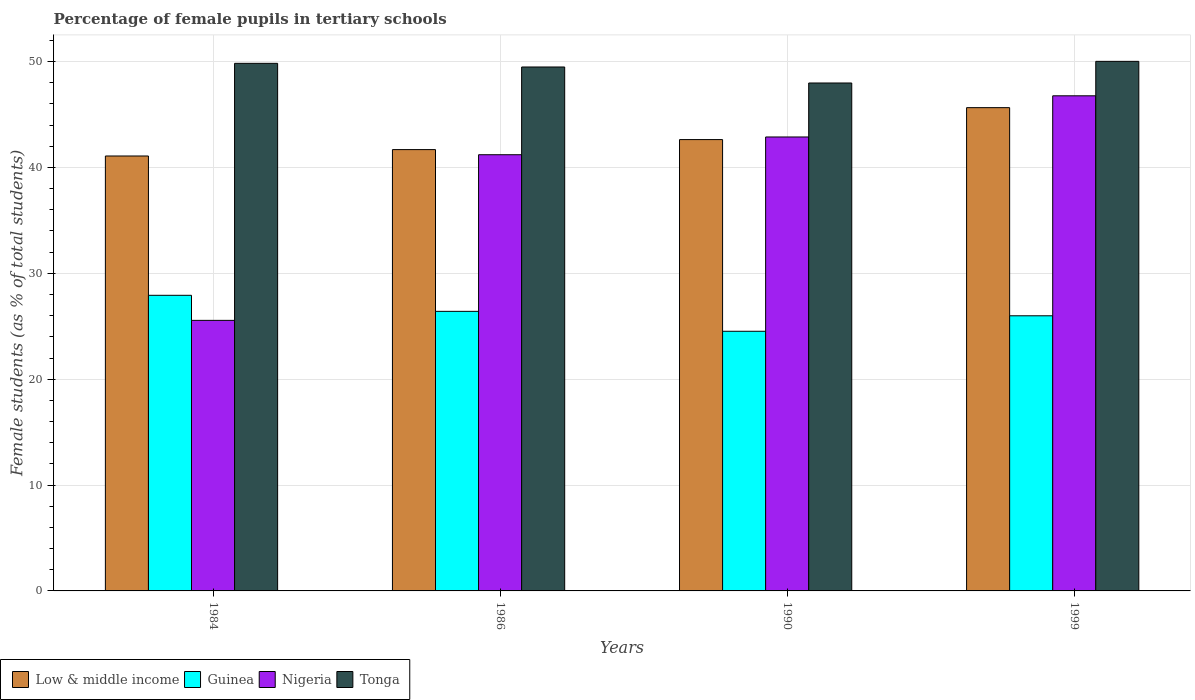How many different coloured bars are there?
Your answer should be very brief. 4. Are the number of bars per tick equal to the number of legend labels?
Ensure brevity in your answer.  Yes. What is the percentage of female pupils in tertiary schools in Tonga in 1999?
Provide a succinct answer. 50.02. Across all years, what is the maximum percentage of female pupils in tertiary schools in Nigeria?
Keep it short and to the point. 46.77. Across all years, what is the minimum percentage of female pupils in tertiary schools in Guinea?
Your response must be concise. 24.52. In which year was the percentage of female pupils in tertiary schools in Low & middle income maximum?
Provide a short and direct response. 1999. What is the total percentage of female pupils in tertiary schools in Guinea in the graph?
Provide a short and direct response. 104.84. What is the difference between the percentage of female pupils in tertiary schools in Tonga in 1984 and that in 1999?
Give a very brief answer. -0.19. What is the difference between the percentage of female pupils in tertiary schools in Nigeria in 1986 and the percentage of female pupils in tertiary schools in Tonga in 1984?
Your answer should be very brief. -8.63. What is the average percentage of female pupils in tertiary schools in Low & middle income per year?
Ensure brevity in your answer.  42.76. In the year 1999, what is the difference between the percentage of female pupils in tertiary schools in Nigeria and percentage of female pupils in tertiary schools in Guinea?
Provide a short and direct response. 20.78. What is the ratio of the percentage of female pupils in tertiary schools in Low & middle income in 1986 to that in 1999?
Make the answer very short. 0.91. What is the difference between the highest and the second highest percentage of female pupils in tertiary schools in Tonga?
Ensure brevity in your answer.  0.19. What is the difference between the highest and the lowest percentage of female pupils in tertiary schools in Guinea?
Provide a succinct answer. 3.4. Is it the case that in every year, the sum of the percentage of female pupils in tertiary schools in Low & middle income and percentage of female pupils in tertiary schools in Tonga is greater than the sum of percentage of female pupils in tertiary schools in Guinea and percentage of female pupils in tertiary schools in Nigeria?
Your answer should be compact. Yes. What does the 4th bar from the left in 1990 represents?
Provide a succinct answer. Tonga. What does the 1st bar from the right in 1986 represents?
Keep it short and to the point. Tonga. How many years are there in the graph?
Provide a short and direct response. 4. Does the graph contain grids?
Make the answer very short. Yes. Where does the legend appear in the graph?
Ensure brevity in your answer.  Bottom left. How many legend labels are there?
Provide a succinct answer. 4. What is the title of the graph?
Keep it short and to the point. Percentage of female pupils in tertiary schools. Does "Other small states" appear as one of the legend labels in the graph?
Give a very brief answer. No. What is the label or title of the Y-axis?
Your answer should be compact. Female students (as % of total students). What is the Female students (as % of total students) in Low & middle income in 1984?
Your response must be concise. 41.08. What is the Female students (as % of total students) in Guinea in 1984?
Make the answer very short. 27.92. What is the Female students (as % of total students) in Nigeria in 1984?
Provide a succinct answer. 25.56. What is the Female students (as % of total students) of Tonga in 1984?
Make the answer very short. 49.83. What is the Female students (as % of total students) in Low & middle income in 1986?
Make the answer very short. 41.69. What is the Female students (as % of total students) of Guinea in 1986?
Provide a succinct answer. 26.41. What is the Female students (as % of total students) of Nigeria in 1986?
Offer a very short reply. 41.2. What is the Female students (as % of total students) in Tonga in 1986?
Provide a short and direct response. 49.49. What is the Female students (as % of total students) in Low & middle income in 1990?
Offer a very short reply. 42.63. What is the Female students (as % of total students) in Guinea in 1990?
Offer a terse response. 24.52. What is the Female students (as % of total students) of Nigeria in 1990?
Provide a succinct answer. 42.88. What is the Female students (as % of total students) of Tonga in 1990?
Give a very brief answer. 47.98. What is the Female students (as % of total students) in Low & middle income in 1999?
Provide a short and direct response. 45.65. What is the Female students (as % of total students) of Guinea in 1999?
Your response must be concise. 25.99. What is the Female students (as % of total students) in Nigeria in 1999?
Make the answer very short. 46.77. What is the Female students (as % of total students) in Tonga in 1999?
Provide a succinct answer. 50.02. Across all years, what is the maximum Female students (as % of total students) of Low & middle income?
Offer a terse response. 45.65. Across all years, what is the maximum Female students (as % of total students) of Guinea?
Provide a short and direct response. 27.92. Across all years, what is the maximum Female students (as % of total students) in Nigeria?
Provide a short and direct response. 46.77. Across all years, what is the maximum Female students (as % of total students) of Tonga?
Offer a very short reply. 50.02. Across all years, what is the minimum Female students (as % of total students) of Low & middle income?
Provide a short and direct response. 41.08. Across all years, what is the minimum Female students (as % of total students) of Guinea?
Provide a short and direct response. 24.52. Across all years, what is the minimum Female students (as % of total students) of Nigeria?
Provide a short and direct response. 25.56. Across all years, what is the minimum Female students (as % of total students) of Tonga?
Give a very brief answer. 47.98. What is the total Female students (as % of total students) in Low & middle income in the graph?
Make the answer very short. 171.04. What is the total Female students (as % of total students) of Guinea in the graph?
Provide a short and direct response. 104.84. What is the total Female students (as % of total students) of Nigeria in the graph?
Your answer should be compact. 156.4. What is the total Female students (as % of total students) in Tonga in the graph?
Offer a terse response. 197.32. What is the difference between the Female students (as % of total students) in Low & middle income in 1984 and that in 1986?
Your answer should be very brief. -0.6. What is the difference between the Female students (as % of total students) in Guinea in 1984 and that in 1986?
Offer a very short reply. 1.52. What is the difference between the Female students (as % of total students) in Nigeria in 1984 and that in 1986?
Offer a terse response. -15.64. What is the difference between the Female students (as % of total students) of Tonga in 1984 and that in 1986?
Your answer should be compact. 0.34. What is the difference between the Female students (as % of total students) in Low & middle income in 1984 and that in 1990?
Offer a very short reply. -1.55. What is the difference between the Female students (as % of total students) in Guinea in 1984 and that in 1990?
Ensure brevity in your answer.  3.4. What is the difference between the Female students (as % of total students) in Nigeria in 1984 and that in 1990?
Provide a succinct answer. -17.32. What is the difference between the Female students (as % of total students) in Tonga in 1984 and that in 1990?
Make the answer very short. 1.86. What is the difference between the Female students (as % of total students) of Low & middle income in 1984 and that in 1999?
Offer a terse response. -4.57. What is the difference between the Female students (as % of total students) of Guinea in 1984 and that in 1999?
Give a very brief answer. 1.93. What is the difference between the Female students (as % of total students) in Nigeria in 1984 and that in 1999?
Give a very brief answer. -21.21. What is the difference between the Female students (as % of total students) in Tonga in 1984 and that in 1999?
Offer a very short reply. -0.19. What is the difference between the Female students (as % of total students) in Low & middle income in 1986 and that in 1990?
Offer a terse response. -0.95. What is the difference between the Female students (as % of total students) of Guinea in 1986 and that in 1990?
Your answer should be compact. 1.88. What is the difference between the Female students (as % of total students) in Nigeria in 1986 and that in 1990?
Your response must be concise. -1.68. What is the difference between the Female students (as % of total students) in Tonga in 1986 and that in 1990?
Provide a short and direct response. 1.51. What is the difference between the Female students (as % of total students) of Low & middle income in 1986 and that in 1999?
Keep it short and to the point. -3.96. What is the difference between the Female students (as % of total students) of Guinea in 1986 and that in 1999?
Give a very brief answer. 0.42. What is the difference between the Female students (as % of total students) of Nigeria in 1986 and that in 1999?
Provide a succinct answer. -5.57. What is the difference between the Female students (as % of total students) of Tonga in 1986 and that in 1999?
Offer a very short reply. -0.53. What is the difference between the Female students (as % of total students) in Low & middle income in 1990 and that in 1999?
Ensure brevity in your answer.  -3.02. What is the difference between the Female students (as % of total students) of Guinea in 1990 and that in 1999?
Your answer should be very brief. -1.46. What is the difference between the Female students (as % of total students) in Nigeria in 1990 and that in 1999?
Make the answer very short. -3.89. What is the difference between the Female students (as % of total students) of Tonga in 1990 and that in 1999?
Offer a very short reply. -2.04. What is the difference between the Female students (as % of total students) in Low & middle income in 1984 and the Female students (as % of total students) in Guinea in 1986?
Your response must be concise. 14.67. What is the difference between the Female students (as % of total students) of Low & middle income in 1984 and the Female students (as % of total students) of Nigeria in 1986?
Provide a succinct answer. -0.12. What is the difference between the Female students (as % of total students) in Low & middle income in 1984 and the Female students (as % of total students) in Tonga in 1986?
Keep it short and to the point. -8.41. What is the difference between the Female students (as % of total students) of Guinea in 1984 and the Female students (as % of total students) of Nigeria in 1986?
Your answer should be compact. -13.28. What is the difference between the Female students (as % of total students) of Guinea in 1984 and the Female students (as % of total students) of Tonga in 1986?
Provide a succinct answer. -21.57. What is the difference between the Female students (as % of total students) in Nigeria in 1984 and the Female students (as % of total students) in Tonga in 1986?
Give a very brief answer. -23.93. What is the difference between the Female students (as % of total students) of Low & middle income in 1984 and the Female students (as % of total students) of Guinea in 1990?
Your response must be concise. 16.56. What is the difference between the Female students (as % of total students) of Low & middle income in 1984 and the Female students (as % of total students) of Nigeria in 1990?
Offer a terse response. -1.8. What is the difference between the Female students (as % of total students) in Low & middle income in 1984 and the Female students (as % of total students) in Tonga in 1990?
Offer a terse response. -6.9. What is the difference between the Female students (as % of total students) of Guinea in 1984 and the Female students (as % of total students) of Nigeria in 1990?
Offer a terse response. -14.96. What is the difference between the Female students (as % of total students) in Guinea in 1984 and the Female students (as % of total students) in Tonga in 1990?
Ensure brevity in your answer.  -20.05. What is the difference between the Female students (as % of total students) of Nigeria in 1984 and the Female students (as % of total students) of Tonga in 1990?
Offer a very short reply. -22.42. What is the difference between the Female students (as % of total students) in Low & middle income in 1984 and the Female students (as % of total students) in Guinea in 1999?
Ensure brevity in your answer.  15.09. What is the difference between the Female students (as % of total students) in Low & middle income in 1984 and the Female students (as % of total students) in Nigeria in 1999?
Offer a terse response. -5.69. What is the difference between the Female students (as % of total students) in Low & middle income in 1984 and the Female students (as % of total students) in Tonga in 1999?
Your response must be concise. -8.94. What is the difference between the Female students (as % of total students) in Guinea in 1984 and the Female students (as % of total students) in Nigeria in 1999?
Provide a short and direct response. -18.84. What is the difference between the Female students (as % of total students) in Guinea in 1984 and the Female students (as % of total students) in Tonga in 1999?
Provide a short and direct response. -22.1. What is the difference between the Female students (as % of total students) of Nigeria in 1984 and the Female students (as % of total students) of Tonga in 1999?
Provide a short and direct response. -24.46. What is the difference between the Female students (as % of total students) in Low & middle income in 1986 and the Female students (as % of total students) in Guinea in 1990?
Provide a short and direct response. 17.16. What is the difference between the Female students (as % of total students) in Low & middle income in 1986 and the Female students (as % of total students) in Nigeria in 1990?
Provide a short and direct response. -1.19. What is the difference between the Female students (as % of total students) of Low & middle income in 1986 and the Female students (as % of total students) of Tonga in 1990?
Provide a short and direct response. -6.29. What is the difference between the Female students (as % of total students) in Guinea in 1986 and the Female students (as % of total students) in Nigeria in 1990?
Ensure brevity in your answer.  -16.47. What is the difference between the Female students (as % of total students) in Guinea in 1986 and the Female students (as % of total students) in Tonga in 1990?
Offer a very short reply. -21.57. What is the difference between the Female students (as % of total students) of Nigeria in 1986 and the Female students (as % of total students) of Tonga in 1990?
Your response must be concise. -6.78. What is the difference between the Female students (as % of total students) in Low & middle income in 1986 and the Female students (as % of total students) in Guinea in 1999?
Ensure brevity in your answer.  15.7. What is the difference between the Female students (as % of total students) in Low & middle income in 1986 and the Female students (as % of total students) in Nigeria in 1999?
Make the answer very short. -5.08. What is the difference between the Female students (as % of total students) in Low & middle income in 1986 and the Female students (as % of total students) in Tonga in 1999?
Your response must be concise. -8.34. What is the difference between the Female students (as % of total students) in Guinea in 1986 and the Female students (as % of total students) in Nigeria in 1999?
Your answer should be very brief. -20.36. What is the difference between the Female students (as % of total students) in Guinea in 1986 and the Female students (as % of total students) in Tonga in 1999?
Keep it short and to the point. -23.61. What is the difference between the Female students (as % of total students) in Nigeria in 1986 and the Female students (as % of total students) in Tonga in 1999?
Make the answer very short. -8.82. What is the difference between the Female students (as % of total students) of Low & middle income in 1990 and the Female students (as % of total students) of Guinea in 1999?
Your answer should be compact. 16.64. What is the difference between the Female students (as % of total students) of Low & middle income in 1990 and the Female students (as % of total students) of Nigeria in 1999?
Offer a very short reply. -4.14. What is the difference between the Female students (as % of total students) in Low & middle income in 1990 and the Female students (as % of total students) in Tonga in 1999?
Offer a very short reply. -7.39. What is the difference between the Female students (as % of total students) of Guinea in 1990 and the Female students (as % of total students) of Nigeria in 1999?
Keep it short and to the point. -22.24. What is the difference between the Female students (as % of total students) of Guinea in 1990 and the Female students (as % of total students) of Tonga in 1999?
Your response must be concise. -25.5. What is the difference between the Female students (as % of total students) of Nigeria in 1990 and the Female students (as % of total students) of Tonga in 1999?
Offer a terse response. -7.14. What is the average Female students (as % of total students) in Low & middle income per year?
Offer a very short reply. 42.76. What is the average Female students (as % of total students) in Guinea per year?
Provide a succinct answer. 26.21. What is the average Female students (as % of total students) of Nigeria per year?
Keep it short and to the point. 39.1. What is the average Female students (as % of total students) in Tonga per year?
Provide a succinct answer. 49.33. In the year 1984, what is the difference between the Female students (as % of total students) in Low & middle income and Female students (as % of total students) in Guinea?
Provide a succinct answer. 13.16. In the year 1984, what is the difference between the Female students (as % of total students) of Low & middle income and Female students (as % of total students) of Nigeria?
Offer a terse response. 15.53. In the year 1984, what is the difference between the Female students (as % of total students) of Low & middle income and Female students (as % of total students) of Tonga?
Your answer should be very brief. -8.75. In the year 1984, what is the difference between the Female students (as % of total students) in Guinea and Female students (as % of total students) in Nigeria?
Your answer should be very brief. 2.37. In the year 1984, what is the difference between the Female students (as % of total students) of Guinea and Female students (as % of total students) of Tonga?
Keep it short and to the point. -21.91. In the year 1984, what is the difference between the Female students (as % of total students) of Nigeria and Female students (as % of total students) of Tonga?
Make the answer very short. -24.28. In the year 1986, what is the difference between the Female students (as % of total students) of Low & middle income and Female students (as % of total students) of Guinea?
Keep it short and to the point. 15.28. In the year 1986, what is the difference between the Female students (as % of total students) of Low & middle income and Female students (as % of total students) of Nigeria?
Keep it short and to the point. 0.48. In the year 1986, what is the difference between the Female students (as % of total students) in Low & middle income and Female students (as % of total students) in Tonga?
Your answer should be compact. -7.8. In the year 1986, what is the difference between the Female students (as % of total students) in Guinea and Female students (as % of total students) in Nigeria?
Offer a terse response. -14.79. In the year 1986, what is the difference between the Female students (as % of total students) of Guinea and Female students (as % of total students) of Tonga?
Offer a terse response. -23.08. In the year 1986, what is the difference between the Female students (as % of total students) in Nigeria and Female students (as % of total students) in Tonga?
Ensure brevity in your answer.  -8.29. In the year 1990, what is the difference between the Female students (as % of total students) of Low & middle income and Female students (as % of total students) of Guinea?
Provide a succinct answer. 18.11. In the year 1990, what is the difference between the Female students (as % of total students) of Low & middle income and Female students (as % of total students) of Nigeria?
Make the answer very short. -0.25. In the year 1990, what is the difference between the Female students (as % of total students) in Low & middle income and Female students (as % of total students) in Tonga?
Make the answer very short. -5.35. In the year 1990, what is the difference between the Female students (as % of total students) in Guinea and Female students (as % of total students) in Nigeria?
Provide a short and direct response. -18.35. In the year 1990, what is the difference between the Female students (as % of total students) in Guinea and Female students (as % of total students) in Tonga?
Provide a short and direct response. -23.45. In the year 1990, what is the difference between the Female students (as % of total students) of Nigeria and Female students (as % of total students) of Tonga?
Ensure brevity in your answer.  -5.1. In the year 1999, what is the difference between the Female students (as % of total students) of Low & middle income and Female students (as % of total students) of Guinea?
Provide a short and direct response. 19.66. In the year 1999, what is the difference between the Female students (as % of total students) in Low & middle income and Female students (as % of total students) in Nigeria?
Keep it short and to the point. -1.12. In the year 1999, what is the difference between the Female students (as % of total students) in Low & middle income and Female students (as % of total students) in Tonga?
Keep it short and to the point. -4.37. In the year 1999, what is the difference between the Female students (as % of total students) of Guinea and Female students (as % of total students) of Nigeria?
Provide a short and direct response. -20.78. In the year 1999, what is the difference between the Female students (as % of total students) of Guinea and Female students (as % of total students) of Tonga?
Ensure brevity in your answer.  -24.03. In the year 1999, what is the difference between the Female students (as % of total students) of Nigeria and Female students (as % of total students) of Tonga?
Make the answer very short. -3.25. What is the ratio of the Female students (as % of total students) in Low & middle income in 1984 to that in 1986?
Offer a very short reply. 0.99. What is the ratio of the Female students (as % of total students) in Guinea in 1984 to that in 1986?
Keep it short and to the point. 1.06. What is the ratio of the Female students (as % of total students) in Nigeria in 1984 to that in 1986?
Provide a short and direct response. 0.62. What is the ratio of the Female students (as % of total students) of Low & middle income in 1984 to that in 1990?
Give a very brief answer. 0.96. What is the ratio of the Female students (as % of total students) of Guinea in 1984 to that in 1990?
Offer a very short reply. 1.14. What is the ratio of the Female students (as % of total students) of Nigeria in 1984 to that in 1990?
Your response must be concise. 0.6. What is the ratio of the Female students (as % of total students) of Tonga in 1984 to that in 1990?
Provide a succinct answer. 1.04. What is the ratio of the Female students (as % of total students) of Guinea in 1984 to that in 1999?
Give a very brief answer. 1.07. What is the ratio of the Female students (as % of total students) in Nigeria in 1984 to that in 1999?
Ensure brevity in your answer.  0.55. What is the ratio of the Female students (as % of total students) in Low & middle income in 1986 to that in 1990?
Provide a succinct answer. 0.98. What is the ratio of the Female students (as % of total students) in Guinea in 1986 to that in 1990?
Your answer should be compact. 1.08. What is the ratio of the Female students (as % of total students) of Nigeria in 1986 to that in 1990?
Provide a succinct answer. 0.96. What is the ratio of the Female students (as % of total students) in Tonga in 1986 to that in 1990?
Your response must be concise. 1.03. What is the ratio of the Female students (as % of total students) in Low & middle income in 1986 to that in 1999?
Give a very brief answer. 0.91. What is the ratio of the Female students (as % of total students) in Guinea in 1986 to that in 1999?
Provide a short and direct response. 1.02. What is the ratio of the Female students (as % of total students) in Nigeria in 1986 to that in 1999?
Provide a short and direct response. 0.88. What is the ratio of the Female students (as % of total students) in Tonga in 1986 to that in 1999?
Offer a very short reply. 0.99. What is the ratio of the Female students (as % of total students) of Low & middle income in 1990 to that in 1999?
Make the answer very short. 0.93. What is the ratio of the Female students (as % of total students) of Guinea in 1990 to that in 1999?
Offer a very short reply. 0.94. What is the ratio of the Female students (as % of total students) of Nigeria in 1990 to that in 1999?
Give a very brief answer. 0.92. What is the ratio of the Female students (as % of total students) of Tonga in 1990 to that in 1999?
Provide a succinct answer. 0.96. What is the difference between the highest and the second highest Female students (as % of total students) of Low & middle income?
Make the answer very short. 3.02. What is the difference between the highest and the second highest Female students (as % of total students) in Guinea?
Your answer should be very brief. 1.52. What is the difference between the highest and the second highest Female students (as % of total students) of Nigeria?
Provide a short and direct response. 3.89. What is the difference between the highest and the second highest Female students (as % of total students) in Tonga?
Your answer should be compact. 0.19. What is the difference between the highest and the lowest Female students (as % of total students) of Low & middle income?
Make the answer very short. 4.57. What is the difference between the highest and the lowest Female students (as % of total students) of Guinea?
Offer a very short reply. 3.4. What is the difference between the highest and the lowest Female students (as % of total students) of Nigeria?
Your answer should be compact. 21.21. What is the difference between the highest and the lowest Female students (as % of total students) in Tonga?
Your answer should be very brief. 2.04. 